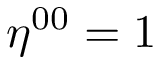Convert formula to latex. <formula><loc_0><loc_0><loc_500><loc_500>\eta ^ { 0 0 } = 1</formula> 